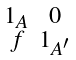Convert formula to latex. <formula><loc_0><loc_0><loc_500><loc_500>\begin{smallmatrix} 1 _ { A } & 0 \\ f & 1 _ { A ^ { \prime } } \end{smallmatrix}</formula> 